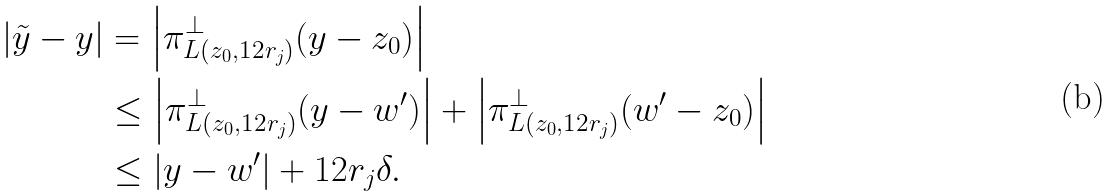Convert formula to latex. <formula><loc_0><loc_0><loc_500><loc_500>| \tilde { y } - y | & = \left | \pi _ { L ( z _ { 0 } , 1 2 r _ { j } ) } ^ { \perp } ( y - z _ { 0 } ) \right | \\ & \leq \left | \pi _ { L ( z _ { 0 } , 1 2 r _ { j } ) } ^ { \perp } ( y - w ^ { \prime } ) \right | + \left | \pi _ { L ( z _ { 0 } , 1 2 r _ { j } ) } ^ { \perp } ( w ^ { \prime } - z _ { 0 } ) \right | \\ & \leq | y - w ^ { \prime } | + 1 2 r _ { j } \delta .</formula> 